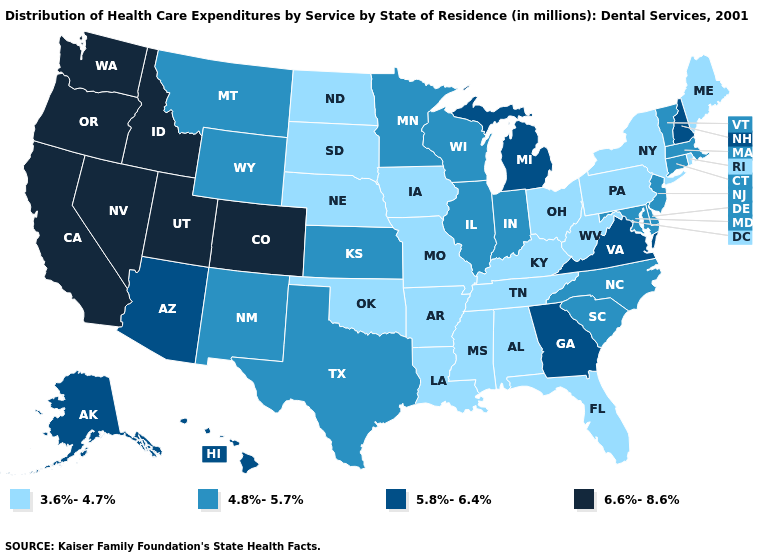Name the states that have a value in the range 4.8%-5.7%?
Quick response, please. Connecticut, Delaware, Illinois, Indiana, Kansas, Maryland, Massachusetts, Minnesota, Montana, New Jersey, New Mexico, North Carolina, South Carolina, Texas, Vermont, Wisconsin, Wyoming. Name the states that have a value in the range 4.8%-5.7%?
Quick response, please. Connecticut, Delaware, Illinois, Indiana, Kansas, Maryland, Massachusetts, Minnesota, Montana, New Jersey, New Mexico, North Carolina, South Carolina, Texas, Vermont, Wisconsin, Wyoming. What is the value of California?
Concise answer only. 6.6%-8.6%. What is the value of California?
Be succinct. 6.6%-8.6%. Does Utah have the highest value in the USA?
Short answer required. Yes. Among the states that border Alabama , which have the highest value?
Write a very short answer. Georgia. Among the states that border New Hampshire , does Massachusetts have the highest value?
Give a very brief answer. Yes. Name the states that have a value in the range 3.6%-4.7%?
Give a very brief answer. Alabama, Arkansas, Florida, Iowa, Kentucky, Louisiana, Maine, Mississippi, Missouri, Nebraska, New York, North Dakota, Ohio, Oklahoma, Pennsylvania, Rhode Island, South Dakota, Tennessee, West Virginia. What is the highest value in states that border Mississippi?
Keep it brief. 3.6%-4.7%. What is the value of Mississippi?
Give a very brief answer. 3.6%-4.7%. What is the lowest value in states that border Wyoming?
Give a very brief answer. 3.6%-4.7%. Which states have the lowest value in the USA?
Answer briefly. Alabama, Arkansas, Florida, Iowa, Kentucky, Louisiana, Maine, Mississippi, Missouri, Nebraska, New York, North Dakota, Ohio, Oklahoma, Pennsylvania, Rhode Island, South Dakota, Tennessee, West Virginia. What is the value of West Virginia?
Be succinct. 3.6%-4.7%. What is the value of North Dakota?
Short answer required. 3.6%-4.7%. Does California have a lower value than Indiana?
Write a very short answer. No. 